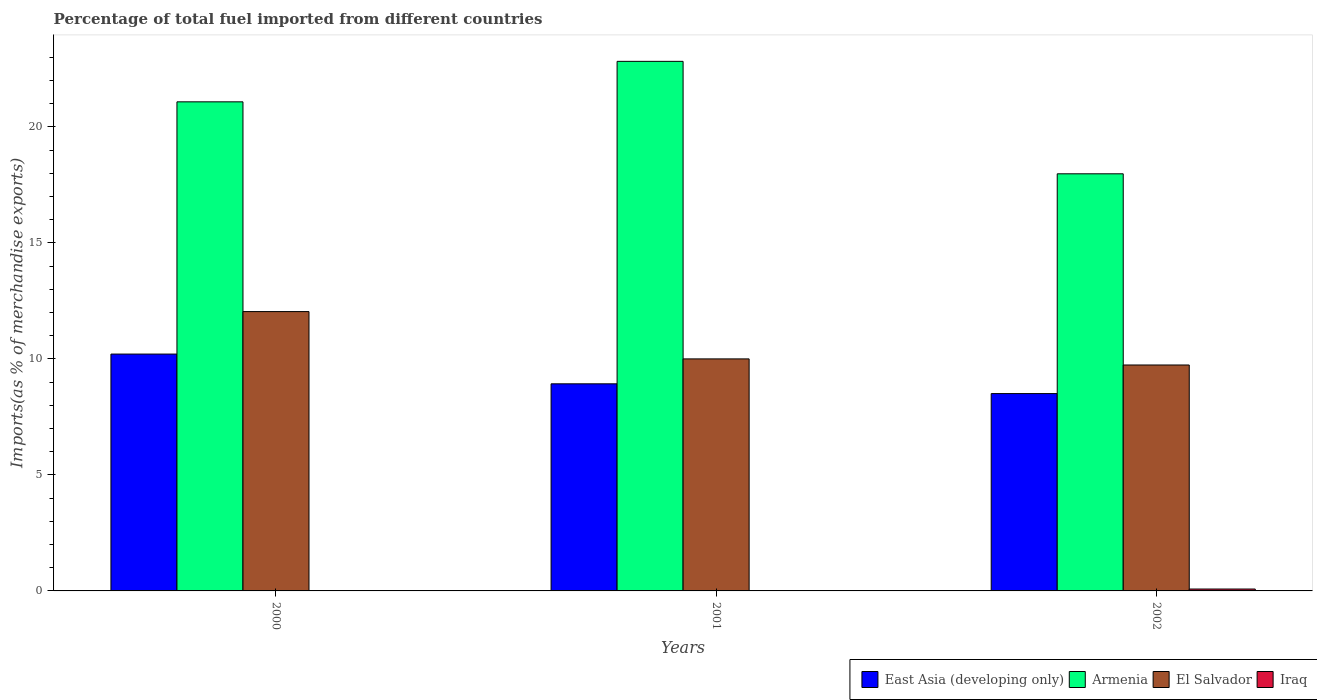How many groups of bars are there?
Give a very brief answer. 3. Are the number of bars per tick equal to the number of legend labels?
Your answer should be very brief. Yes. Are the number of bars on each tick of the X-axis equal?
Provide a succinct answer. Yes. What is the label of the 2nd group of bars from the left?
Offer a very short reply. 2001. What is the percentage of imports to different countries in East Asia (developing only) in 2002?
Provide a short and direct response. 8.5. Across all years, what is the maximum percentage of imports to different countries in Iraq?
Ensure brevity in your answer.  0.08. Across all years, what is the minimum percentage of imports to different countries in Armenia?
Make the answer very short. 17.98. In which year was the percentage of imports to different countries in El Salvador maximum?
Give a very brief answer. 2000. In which year was the percentage of imports to different countries in El Salvador minimum?
Your response must be concise. 2002. What is the total percentage of imports to different countries in El Salvador in the graph?
Your response must be concise. 31.77. What is the difference between the percentage of imports to different countries in Iraq in 2001 and that in 2002?
Your response must be concise. -0.07. What is the difference between the percentage of imports to different countries in Armenia in 2000 and the percentage of imports to different countries in Iraq in 2001?
Your answer should be very brief. 21.06. What is the average percentage of imports to different countries in El Salvador per year?
Provide a succinct answer. 10.59. In the year 2000, what is the difference between the percentage of imports to different countries in El Salvador and percentage of imports to different countries in Iraq?
Provide a short and direct response. 12.02. In how many years, is the percentage of imports to different countries in Armenia greater than 9 %?
Provide a short and direct response. 3. What is the ratio of the percentage of imports to different countries in Iraq in 2000 to that in 2001?
Offer a terse response. 0.96. Is the difference between the percentage of imports to different countries in El Salvador in 2000 and 2001 greater than the difference between the percentage of imports to different countries in Iraq in 2000 and 2001?
Make the answer very short. Yes. What is the difference between the highest and the second highest percentage of imports to different countries in El Salvador?
Ensure brevity in your answer.  2.04. What is the difference between the highest and the lowest percentage of imports to different countries in Armenia?
Keep it short and to the point. 4.85. Is the sum of the percentage of imports to different countries in El Salvador in 2000 and 2002 greater than the maximum percentage of imports to different countries in Armenia across all years?
Your answer should be very brief. No. What does the 3rd bar from the left in 2001 represents?
Give a very brief answer. El Salvador. What does the 4th bar from the right in 2002 represents?
Provide a short and direct response. East Asia (developing only). Is it the case that in every year, the sum of the percentage of imports to different countries in Armenia and percentage of imports to different countries in El Salvador is greater than the percentage of imports to different countries in Iraq?
Offer a very short reply. Yes. Are the values on the major ticks of Y-axis written in scientific E-notation?
Your answer should be compact. No. Does the graph contain any zero values?
Make the answer very short. No. Does the graph contain grids?
Provide a short and direct response. No. What is the title of the graph?
Your answer should be compact. Percentage of total fuel imported from different countries. What is the label or title of the X-axis?
Ensure brevity in your answer.  Years. What is the label or title of the Y-axis?
Offer a terse response. Imports(as % of merchandise exports). What is the Imports(as % of merchandise exports) in East Asia (developing only) in 2000?
Your response must be concise. 10.21. What is the Imports(as % of merchandise exports) in Armenia in 2000?
Give a very brief answer. 21.08. What is the Imports(as % of merchandise exports) of El Salvador in 2000?
Your answer should be compact. 12.04. What is the Imports(as % of merchandise exports) in Iraq in 2000?
Provide a succinct answer. 0.01. What is the Imports(as % of merchandise exports) of East Asia (developing only) in 2001?
Offer a very short reply. 8.93. What is the Imports(as % of merchandise exports) in Armenia in 2001?
Provide a short and direct response. 22.82. What is the Imports(as % of merchandise exports) of El Salvador in 2001?
Your response must be concise. 10. What is the Imports(as % of merchandise exports) in Iraq in 2001?
Provide a short and direct response. 0.02. What is the Imports(as % of merchandise exports) of East Asia (developing only) in 2002?
Keep it short and to the point. 8.5. What is the Imports(as % of merchandise exports) in Armenia in 2002?
Your answer should be very brief. 17.98. What is the Imports(as % of merchandise exports) in El Salvador in 2002?
Offer a terse response. 9.74. What is the Imports(as % of merchandise exports) of Iraq in 2002?
Your response must be concise. 0.08. Across all years, what is the maximum Imports(as % of merchandise exports) in East Asia (developing only)?
Your response must be concise. 10.21. Across all years, what is the maximum Imports(as % of merchandise exports) of Armenia?
Ensure brevity in your answer.  22.82. Across all years, what is the maximum Imports(as % of merchandise exports) in El Salvador?
Provide a short and direct response. 12.04. Across all years, what is the maximum Imports(as % of merchandise exports) in Iraq?
Provide a short and direct response. 0.08. Across all years, what is the minimum Imports(as % of merchandise exports) of East Asia (developing only)?
Your answer should be compact. 8.5. Across all years, what is the minimum Imports(as % of merchandise exports) of Armenia?
Offer a terse response. 17.98. Across all years, what is the minimum Imports(as % of merchandise exports) of El Salvador?
Offer a terse response. 9.74. Across all years, what is the minimum Imports(as % of merchandise exports) of Iraq?
Your response must be concise. 0.01. What is the total Imports(as % of merchandise exports) in East Asia (developing only) in the graph?
Keep it short and to the point. 27.64. What is the total Imports(as % of merchandise exports) in Armenia in the graph?
Provide a short and direct response. 61.88. What is the total Imports(as % of merchandise exports) of El Salvador in the graph?
Ensure brevity in your answer.  31.77. What is the total Imports(as % of merchandise exports) in Iraq in the graph?
Provide a succinct answer. 0.11. What is the difference between the Imports(as % of merchandise exports) in East Asia (developing only) in 2000 and that in 2001?
Offer a terse response. 1.28. What is the difference between the Imports(as % of merchandise exports) of Armenia in 2000 and that in 2001?
Your answer should be very brief. -1.74. What is the difference between the Imports(as % of merchandise exports) of El Salvador in 2000 and that in 2001?
Your response must be concise. 2.04. What is the difference between the Imports(as % of merchandise exports) in Iraq in 2000 and that in 2001?
Provide a short and direct response. -0. What is the difference between the Imports(as % of merchandise exports) in East Asia (developing only) in 2000 and that in 2002?
Give a very brief answer. 1.7. What is the difference between the Imports(as % of merchandise exports) in Armenia in 2000 and that in 2002?
Your answer should be very brief. 3.1. What is the difference between the Imports(as % of merchandise exports) in El Salvador in 2000 and that in 2002?
Your response must be concise. 2.3. What is the difference between the Imports(as % of merchandise exports) of Iraq in 2000 and that in 2002?
Make the answer very short. -0.07. What is the difference between the Imports(as % of merchandise exports) in East Asia (developing only) in 2001 and that in 2002?
Your answer should be very brief. 0.42. What is the difference between the Imports(as % of merchandise exports) in Armenia in 2001 and that in 2002?
Offer a very short reply. 4.85. What is the difference between the Imports(as % of merchandise exports) of El Salvador in 2001 and that in 2002?
Offer a terse response. 0.26. What is the difference between the Imports(as % of merchandise exports) in Iraq in 2001 and that in 2002?
Offer a very short reply. -0.07. What is the difference between the Imports(as % of merchandise exports) of East Asia (developing only) in 2000 and the Imports(as % of merchandise exports) of Armenia in 2001?
Give a very brief answer. -12.62. What is the difference between the Imports(as % of merchandise exports) of East Asia (developing only) in 2000 and the Imports(as % of merchandise exports) of El Salvador in 2001?
Your answer should be very brief. 0.21. What is the difference between the Imports(as % of merchandise exports) in East Asia (developing only) in 2000 and the Imports(as % of merchandise exports) in Iraq in 2001?
Provide a succinct answer. 10.19. What is the difference between the Imports(as % of merchandise exports) in Armenia in 2000 and the Imports(as % of merchandise exports) in El Salvador in 2001?
Offer a very short reply. 11.08. What is the difference between the Imports(as % of merchandise exports) of Armenia in 2000 and the Imports(as % of merchandise exports) of Iraq in 2001?
Offer a very short reply. 21.06. What is the difference between the Imports(as % of merchandise exports) of El Salvador in 2000 and the Imports(as % of merchandise exports) of Iraq in 2001?
Your response must be concise. 12.02. What is the difference between the Imports(as % of merchandise exports) in East Asia (developing only) in 2000 and the Imports(as % of merchandise exports) in Armenia in 2002?
Make the answer very short. -7.77. What is the difference between the Imports(as % of merchandise exports) in East Asia (developing only) in 2000 and the Imports(as % of merchandise exports) in El Salvador in 2002?
Your answer should be compact. 0.47. What is the difference between the Imports(as % of merchandise exports) of East Asia (developing only) in 2000 and the Imports(as % of merchandise exports) of Iraq in 2002?
Keep it short and to the point. 10.13. What is the difference between the Imports(as % of merchandise exports) of Armenia in 2000 and the Imports(as % of merchandise exports) of El Salvador in 2002?
Your answer should be compact. 11.34. What is the difference between the Imports(as % of merchandise exports) of Armenia in 2000 and the Imports(as % of merchandise exports) of Iraq in 2002?
Provide a short and direct response. 21. What is the difference between the Imports(as % of merchandise exports) in El Salvador in 2000 and the Imports(as % of merchandise exports) in Iraq in 2002?
Your answer should be compact. 11.96. What is the difference between the Imports(as % of merchandise exports) of East Asia (developing only) in 2001 and the Imports(as % of merchandise exports) of Armenia in 2002?
Ensure brevity in your answer.  -9.05. What is the difference between the Imports(as % of merchandise exports) in East Asia (developing only) in 2001 and the Imports(as % of merchandise exports) in El Salvador in 2002?
Provide a short and direct response. -0.81. What is the difference between the Imports(as % of merchandise exports) of East Asia (developing only) in 2001 and the Imports(as % of merchandise exports) of Iraq in 2002?
Give a very brief answer. 8.84. What is the difference between the Imports(as % of merchandise exports) in Armenia in 2001 and the Imports(as % of merchandise exports) in El Salvador in 2002?
Your answer should be compact. 13.09. What is the difference between the Imports(as % of merchandise exports) in Armenia in 2001 and the Imports(as % of merchandise exports) in Iraq in 2002?
Give a very brief answer. 22.74. What is the difference between the Imports(as % of merchandise exports) in El Salvador in 2001 and the Imports(as % of merchandise exports) in Iraq in 2002?
Make the answer very short. 9.92. What is the average Imports(as % of merchandise exports) of East Asia (developing only) per year?
Provide a short and direct response. 9.21. What is the average Imports(as % of merchandise exports) in Armenia per year?
Keep it short and to the point. 20.63. What is the average Imports(as % of merchandise exports) of El Salvador per year?
Your answer should be compact. 10.59. What is the average Imports(as % of merchandise exports) in Iraq per year?
Offer a terse response. 0.04. In the year 2000, what is the difference between the Imports(as % of merchandise exports) of East Asia (developing only) and Imports(as % of merchandise exports) of Armenia?
Provide a short and direct response. -10.87. In the year 2000, what is the difference between the Imports(as % of merchandise exports) of East Asia (developing only) and Imports(as % of merchandise exports) of El Salvador?
Provide a short and direct response. -1.83. In the year 2000, what is the difference between the Imports(as % of merchandise exports) in East Asia (developing only) and Imports(as % of merchandise exports) in Iraq?
Make the answer very short. 10.19. In the year 2000, what is the difference between the Imports(as % of merchandise exports) of Armenia and Imports(as % of merchandise exports) of El Salvador?
Offer a terse response. 9.04. In the year 2000, what is the difference between the Imports(as % of merchandise exports) of Armenia and Imports(as % of merchandise exports) of Iraq?
Give a very brief answer. 21.06. In the year 2000, what is the difference between the Imports(as % of merchandise exports) in El Salvador and Imports(as % of merchandise exports) in Iraq?
Your answer should be very brief. 12.02. In the year 2001, what is the difference between the Imports(as % of merchandise exports) in East Asia (developing only) and Imports(as % of merchandise exports) in Armenia?
Make the answer very short. -13.9. In the year 2001, what is the difference between the Imports(as % of merchandise exports) of East Asia (developing only) and Imports(as % of merchandise exports) of El Salvador?
Your answer should be compact. -1.07. In the year 2001, what is the difference between the Imports(as % of merchandise exports) in East Asia (developing only) and Imports(as % of merchandise exports) in Iraq?
Keep it short and to the point. 8.91. In the year 2001, what is the difference between the Imports(as % of merchandise exports) of Armenia and Imports(as % of merchandise exports) of El Salvador?
Your answer should be very brief. 12.82. In the year 2001, what is the difference between the Imports(as % of merchandise exports) in Armenia and Imports(as % of merchandise exports) in Iraq?
Give a very brief answer. 22.81. In the year 2001, what is the difference between the Imports(as % of merchandise exports) of El Salvador and Imports(as % of merchandise exports) of Iraq?
Make the answer very short. 9.98. In the year 2002, what is the difference between the Imports(as % of merchandise exports) in East Asia (developing only) and Imports(as % of merchandise exports) in Armenia?
Your answer should be very brief. -9.47. In the year 2002, what is the difference between the Imports(as % of merchandise exports) of East Asia (developing only) and Imports(as % of merchandise exports) of El Salvador?
Your answer should be very brief. -1.23. In the year 2002, what is the difference between the Imports(as % of merchandise exports) of East Asia (developing only) and Imports(as % of merchandise exports) of Iraq?
Your answer should be very brief. 8.42. In the year 2002, what is the difference between the Imports(as % of merchandise exports) in Armenia and Imports(as % of merchandise exports) in El Salvador?
Offer a terse response. 8.24. In the year 2002, what is the difference between the Imports(as % of merchandise exports) of Armenia and Imports(as % of merchandise exports) of Iraq?
Your answer should be compact. 17.89. In the year 2002, what is the difference between the Imports(as % of merchandise exports) of El Salvador and Imports(as % of merchandise exports) of Iraq?
Keep it short and to the point. 9.66. What is the ratio of the Imports(as % of merchandise exports) of East Asia (developing only) in 2000 to that in 2001?
Keep it short and to the point. 1.14. What is the ratio of the Imports(as % of merchandise exports) in Armenia in 2000 to that in 2001?
Your response must be concise. 0.92. What is the ratio of the Imports(as % of merchandise exports) in El Salvador in 2000 to that in 2001?
Offer a terse response. 1.2. What is the ratio of the Imports(as % of merchandise exports) of Iraq in 2000 to that in 2001?
Offer a terse response. 0.96. What is the ratio of the Imports(as % of merchandise exports) in East Asia (developing only) in 2000 to that in 2002?
Make the answer very short. 1.2. What is the ratio of the Imports(as % of merchandise exports) of Armenia in 2000 to that in 2002?
Your response must be concise. 1.17. What is the ratio of the Imports(as % of merchandise exports) in El Salvador in 2000 to that in 2002?
Your response must be concise. 1.24. What is the ratio of the Imports(as % of merchandise exports) in Iraq in 2000 to that in 2002?
Provide a short and direct response. 0.18. What is the ratio of the Imports(as % of merchandise exports) in East Asia (developing only) in 2001 to that in 2002?
Provide a succinct answer. 1.05. What is the ratio of the Imports(as % of merchandise exports) of Armenia in 2001 to that in 2002?
Your response must be concise. 1.27. What is the ratio of the Imports(as % of merchandise exports) in El Salvador in 2001 to that in 2002?
Your answer should be compact. 1.03. What is the ratio of the Imports(as % of merchandise exports) in Iraq in 2001 to that in 2002?
Your answer should be compact. 0.19. What is the difference between the highest and the second highest Imports(as % of merchandise exports) in East Asia (developing only)?
Your answer should be compact. 1.28. What is the difference between the highest and the second highest Imports(as % of merchandise exports) in Armenia?
Provide a succinct answer. 1.74. What is the difference between the highest and the second highest Imports(as % of merchandise exports) of El Salvador?
Give a very brief answer. 2.04. What is the difference between the highest and the second highest Imports(as % of merchandise exports) of Iraq?
Keep it short and to the point. 0.07. What is the difference between the highest and the lowest Imports(as % of merchandise exports) in East Asia (developing only)?
Provide a succinct answer. 1.7. What is the difference between the highest and the lowest Imports(as % of merchandise exports) of Armenia?
Ensure brevity in your answer.  4.85. What is the difference between the highest and the lowest Imports(as % of merchandise exports) in El Salvador?
Provide a short and direct response. 2.3. What is the difference between the highest and the lowest Imports(as % of merchandise exports) in Iraq?
Offer a very short reply. 0.07. 